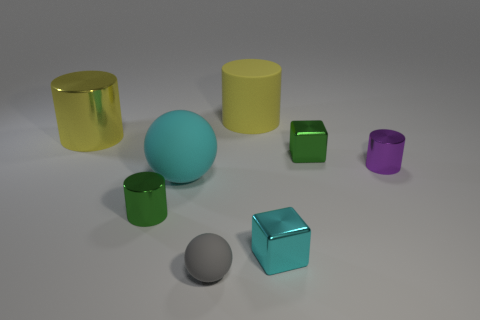How many objects are there in total, and can you categorize them by size? There are a total of seven objects in the image. Categorizing them by size, we have two large cylinders (one yellow and one green), one large cube (teal), two small cylinders (one green and one purple), one medium-sized sphere (cyan), and one tiny sphere (gray).  Are there any patterns or symmetry in how the objects are arranged? The objects do not seem to be arranged in any particular pattern or symmetry. They are scattered across the surface with varying distances between them, creating a random and natural composition. 